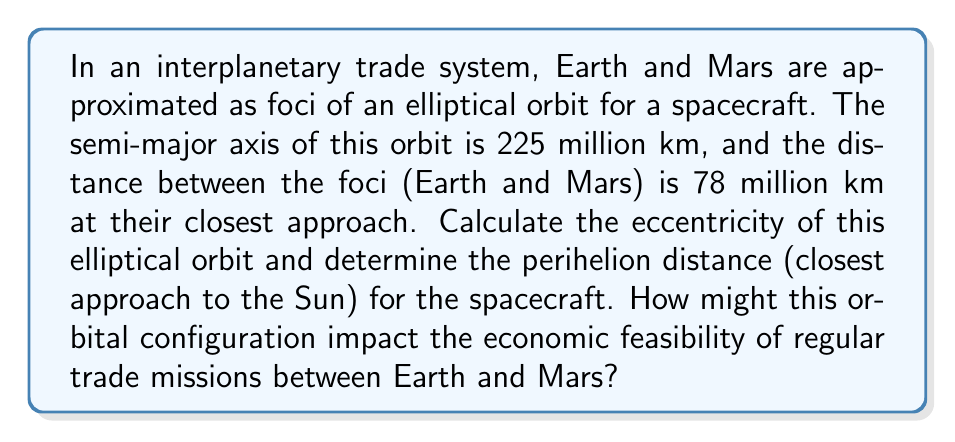Show me your answer to this math problem. To solve this problem, we'll use the properties of ellipses and conic sections:

1. Calculate the eccentricity:
   The eccentricity (e) of an ellipse is given by the ratio of the distance between the foci (c) to the length of the semi-major axis (a):

   $$e = \frac{c}{a}$$

   We know that the distance between the foci is 78 million km, so c = 39 million km (half of 78).
   The semi-major axis (a) is given as 225 million km.

   $$e = \frac{39}{225} = 0.1733$$

2. Calculate the perihelion distance:
   The perihelion distance (q) is the distance from the focus (in this case, the Sun) to the closest point on the ellipse. It's given by:

   $$q = a(1-e)$$

   Substituting our values:

   $$q = 225(1-0.1733) = 225 \times 0.8267 = 186.0075\text{ million km}$$

Economic implications:
1. Fuel efficiency: The low eccentricity (0.1733) indicates a nearly circular orbit, which is generally more fuel-efficient for regular missions compared to highly elliptical orbits.
2. Travel time: The perihelion distance of 186 million km suggests that the spacecraft comes relatively close to the Sun, potentially allowing for faster travel times between Earth and Mars when they are properly aligned.
3. Mission frequency: The orbital configuration allows for regular trade missions, potentially increasing the economic viability of interplanetary commerce.
4. Infrastructure costs: The consistent orbit may allow for the establishment of permanent refueling or waypoint stations, spreading infrastructure costs over multiple missions.
5. Risk assessment: The predictable nature of the orbit can help in better risk assessment and insurance pricing for interplanetary cargo.

These factors combined suggest that this orbital configuration could support economically feasible regular trade missions between Earth and Mars, assuming technological capabilities for efficient propulsion and life support systems.
Answer: Eccentricity: 0.1733
Perihelion distance: 186.0075 million km 